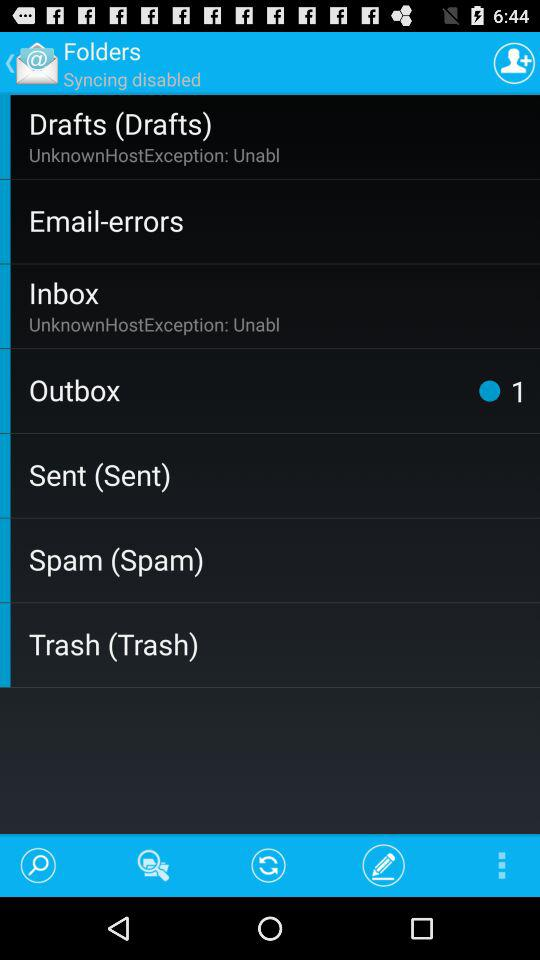How many emails are there in "Outbox"? There is one email in "Outbox". 